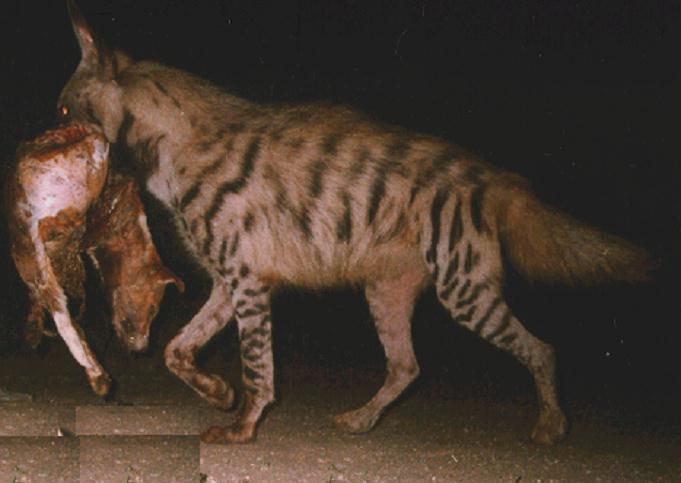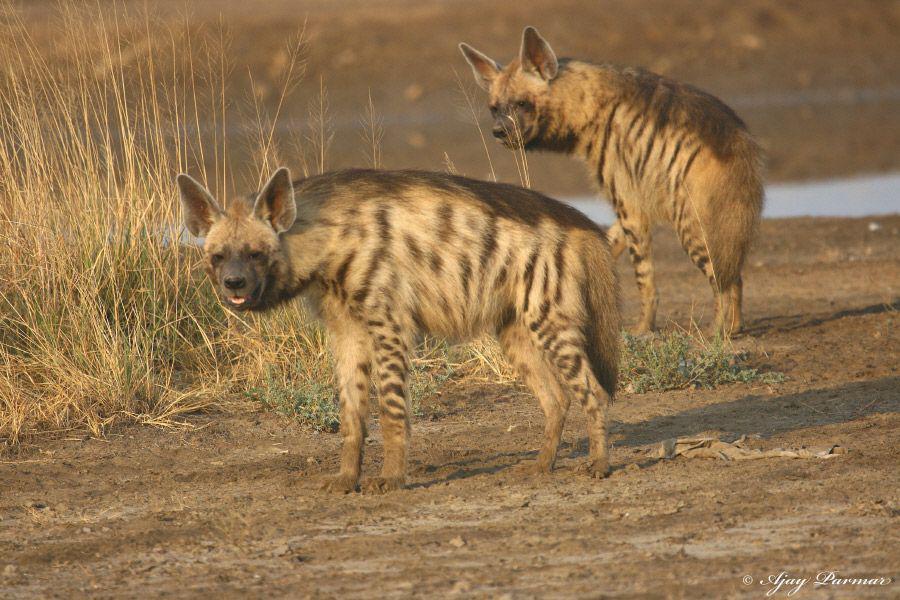The first image is the image on the left, the second image is the image on the right. Assess this claim about the two images: "there are at least three hyenas in the image on the left". Correct or not? Answer yes or no. No. The first image is the image on the left, the second image is the image on the right. Analyze the images presented: Is the assertion "There is one baby hyena." valid? Answer yes or no. No. 